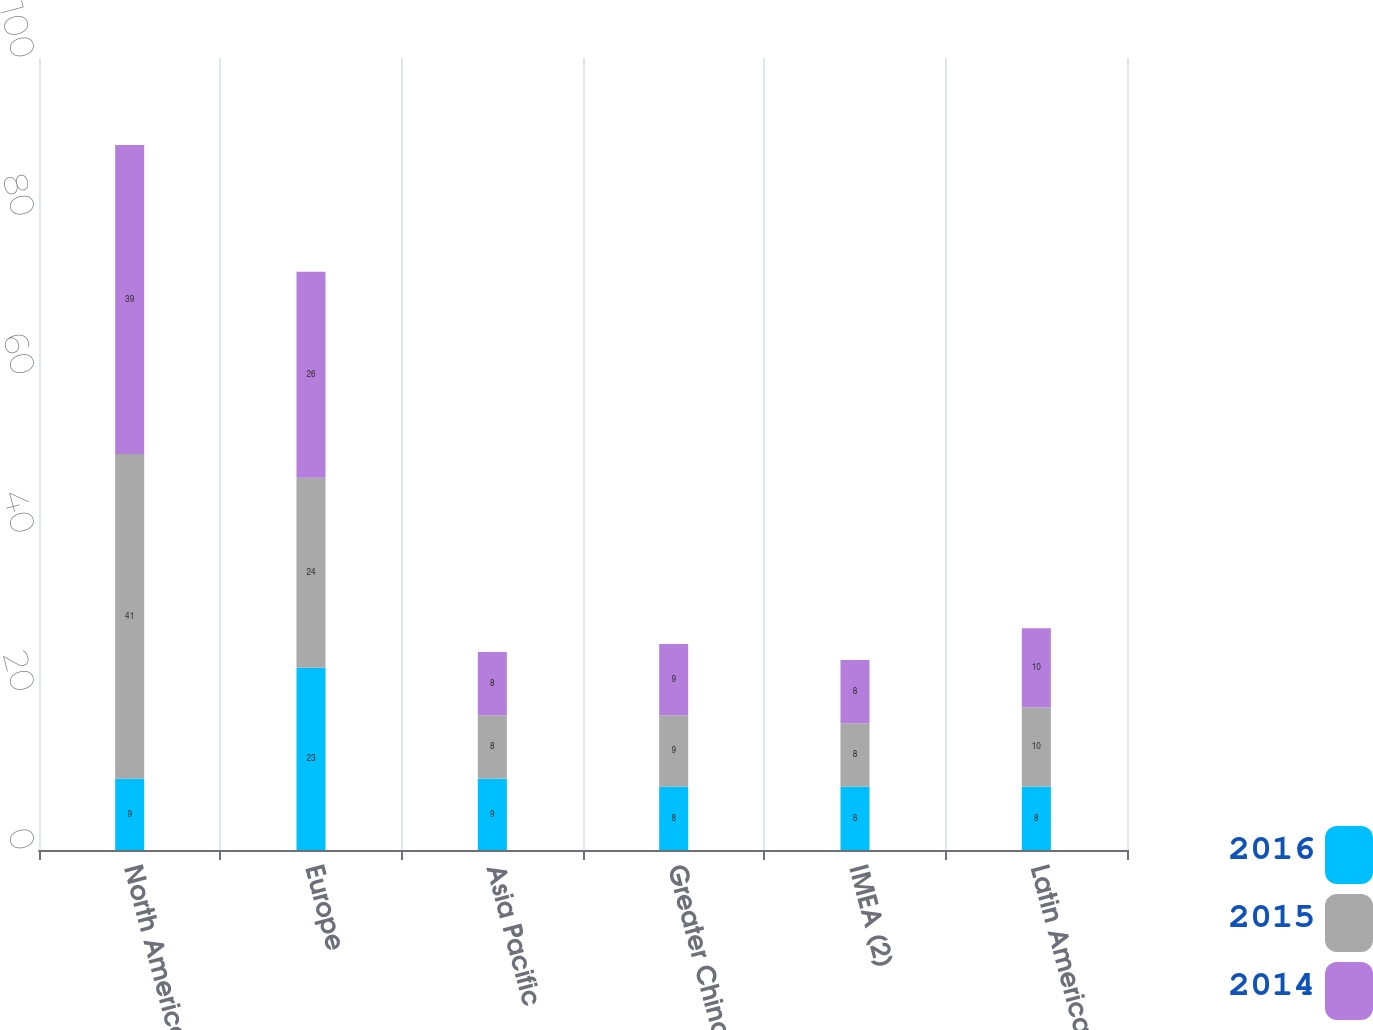Convert chart to OTSL. <chart><loc_0><loc_0><loc_500><loc_500><stacked_bar_chart><ecel><fcel>North America (1)<fcel>Europe<fcel>Asia Pacific<fcel>Greater China<fcel>IMEA (2)<fcel>Latin America<nl><fcel>2016<fcel>9<fcel>23<fcel>9<fcel>8<fcel>8<fcel>8<nl><fcel>2015<fcel>41<fcel>24<fcel>8<fcel>9<fcel>8<fcel>10<nl><fcel>2014<fcel>39<fcel>26<fcel>8<fcel>9<fcel>8<fcel>10<nl></chart> 